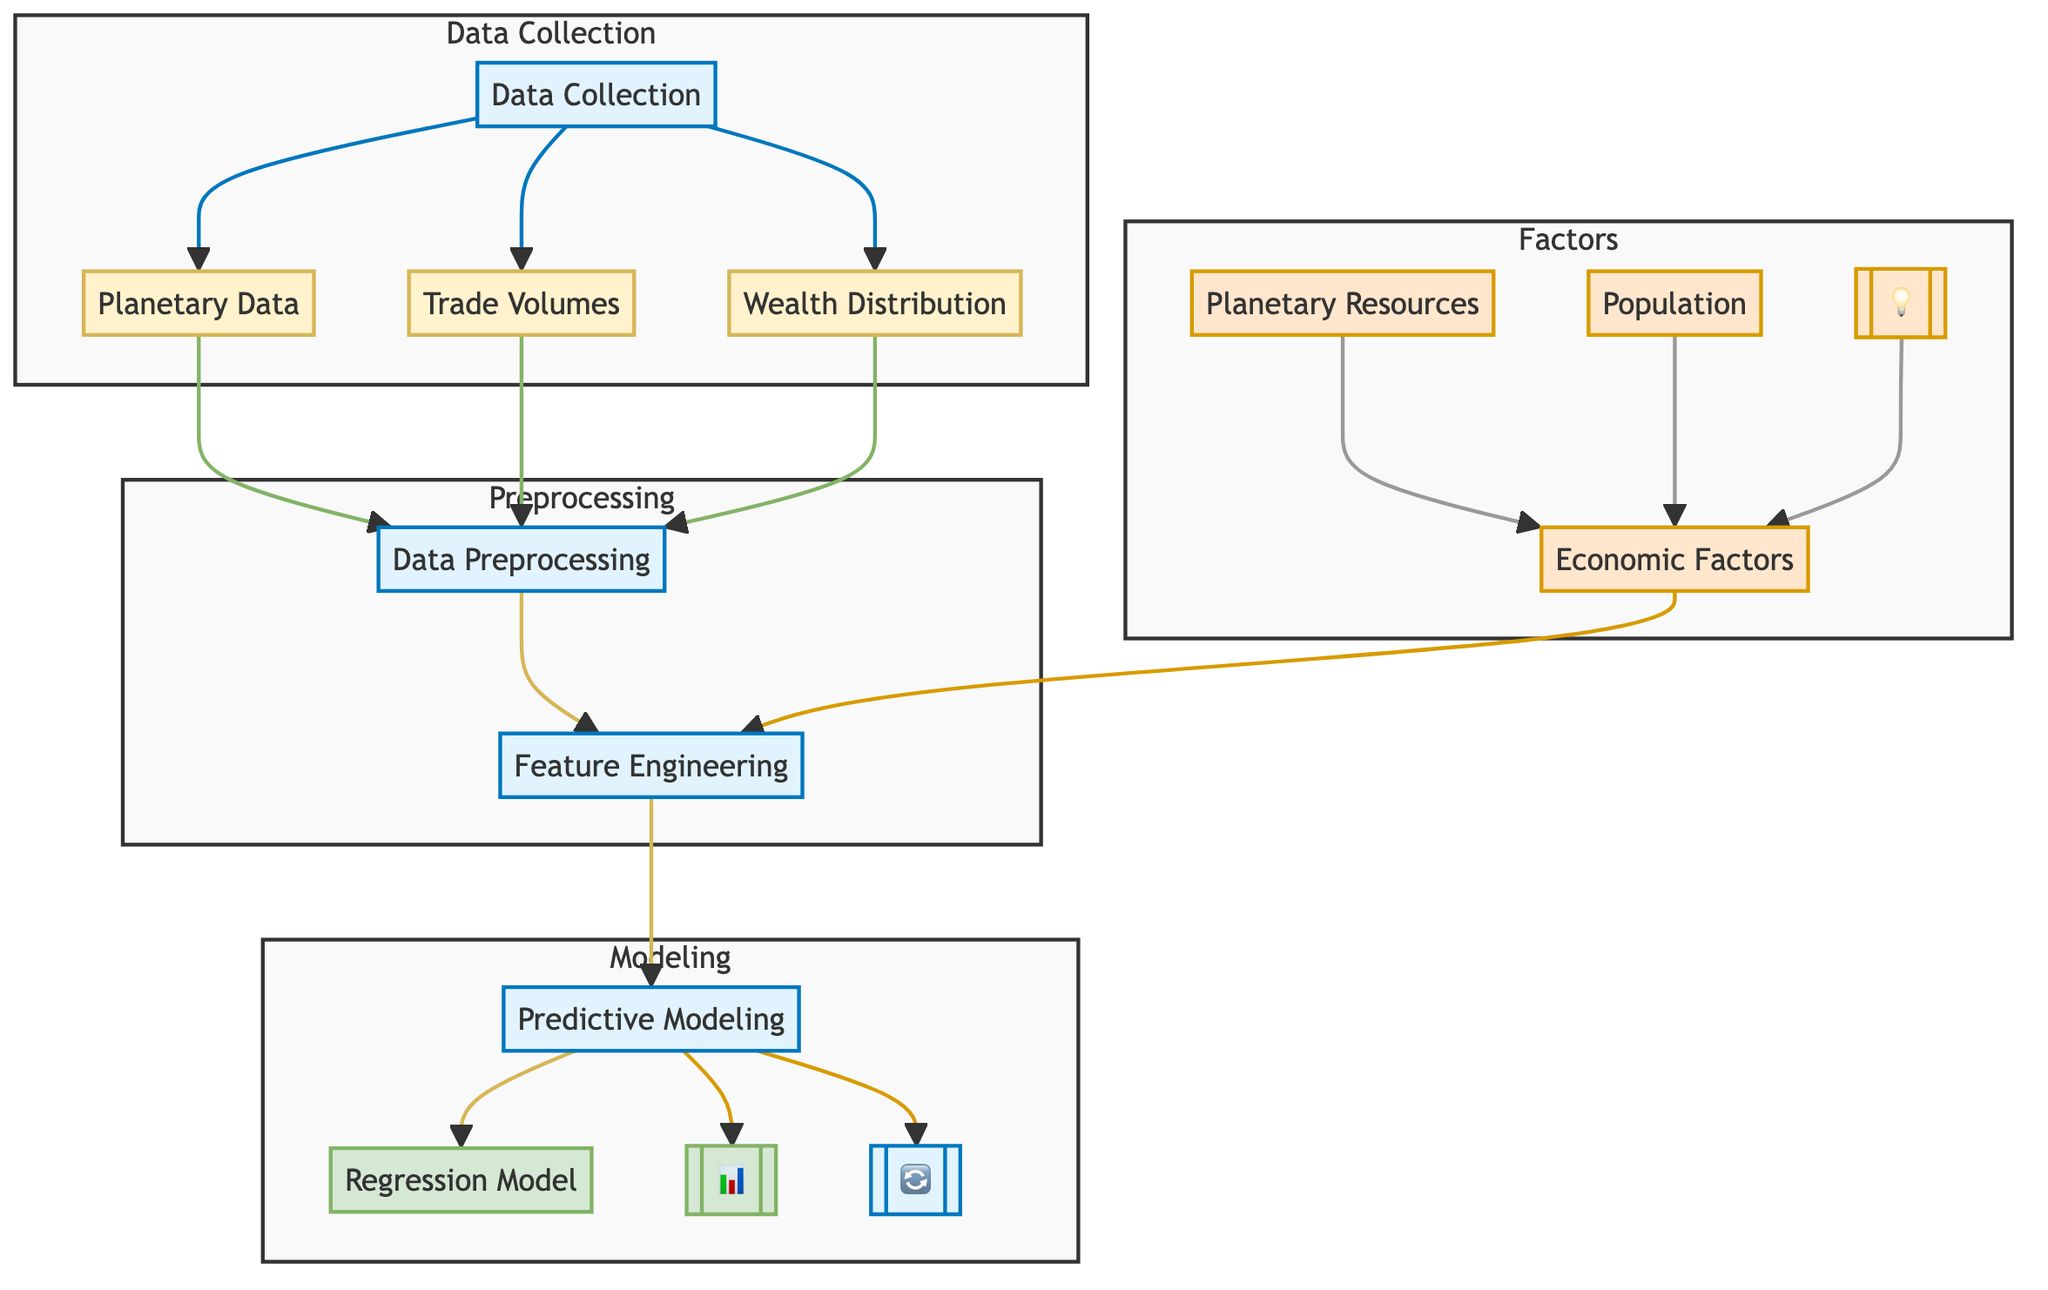What is the first step in the diagram? The first step is 'Data Collection,' which is represented as a process node at the top of the diagram. It collects data related to planetary, trade volume, and wealth distribution.
Answer: Data Collection How many model types are present in the modeling phase? The modeling phase includes two model types: 'Regression Model' and 'Neural Network.' These are depicted as model nodes under the 'Modeling' subgraph.
Answer: Two What are the three types of data collected? The data collected includes 'Planetary Data,' 'Trade Volumes,' and 'Wealth Distribution,' represented as data nodes branching from the 'Data Collection' process.
Answer: Planetary Data, Trade Volumes, Wealth Distribution Which factors influence feature engineering? The factors influencing feature engineering are 'Economic Factors,' 'Planetary Resources,' 'Population,' and 'Political Stability,' depicted as factor nodes feeding into the feature engineering process.
Answer: Economic Factors, Planetary Resources, Population, Political Stability What process follows data preprocessing? The process that follows data preprocessing is 'Feature Engineering,' indicated by an arrow leading from data preprocessing to this process node.
Answer: Feature Engineering What is the output of the predictive modeling phase? The output of the predictive modeling phase consists of two models: 'Regression Model' and 'Neural Network,' which are shown as the final outputs of the predictive modeling process.
Answer: Regression Model, Neural Network Which subgraph summarizes economic interactions in the diagram? The subgraph that summarizes economic interactions is labeled 'Factors,' where various factors influencing trade and economic exchanges are defined and linked, suggesting their role in the overall analysis.
Answer: Factors How does feature engineering relate to economic factors? Feature engineering is influenced by economic factors, which are represented as linked factors that feed into the feature engineering process within the diagram.
Answer: Influenced What does the 'Model Evaluation' process assess? The 'Model Evaluation' process assesses the performance of the predictive models, ensuring their effectiveness and accuracy in predicting trade volumes and wealth distribution based on the engineered features.
Answer: Predictive Models' Performance 